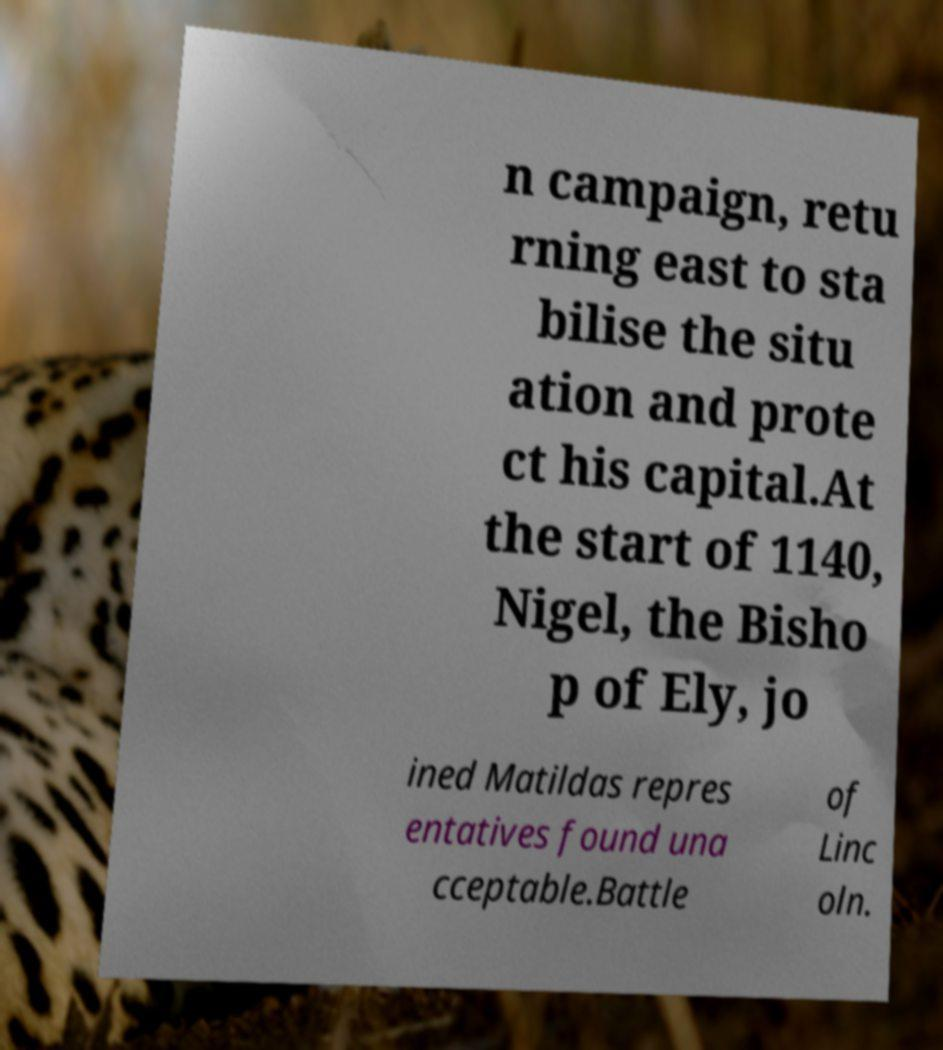Could you assist in decoding the text presented in this image and type it out clearly? n campaign, retu rning east to sta bilise the situ ation and prote ct his capital.At the start of 1140, Nigel, the Bisho p of Ely, jo ined Matildas repres entatives found una cceptable.Battle of Linc oln. 